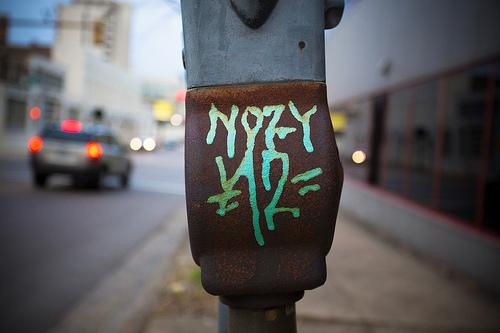Can you count how many cars are depicted in the image and their actions? There are two cars in the image; one is driving away from the scene, and the other is driving towards it with bright headlights on. Based on the image, identify two potential safety issues present. A possible safety issue is the old, rusty parking meter with a small hole, and another issue is the blurred vision of cars and buildings, making the scene unclear. Describe the sentiment or mood conveyed by the image. The mood of the image can be perceived as urban, chaotic, and somewhat neglected due to the rusty parking meter, graffiti and blurry quality. Examine the quality of the image and provide a brief description. The image has an outdoor setting and appears to be blurry, making some elements difficult to comprehend clearly. How many objects in the image are in motion? Explain what they are doing. There are three objects in motion: a silver vehicle driving down the street, a car with bright headlights in traffic, and an SUV driving down the road. List the features of the buildings seen in the background. The buildings have large windows, rust-red window frames, and are slightly out of focus. Are there any traffic lights in the image? If yes, please describe them. Yes, there is a yellow traffic light on a post, which might be a stoplight. What is the primary object mentioned in the image and its condition? The primary object in the image is a rusty parking meter with graffiti on it. Discuss the state of the parking meter in more detail. The parking meter is old and rusty with a small hole, a gray pole, and a metal latch. There is green graffiti that reads "nozy 12" on it. Identify the color and content of the graffiti on the parking meter. The graffiti is green and it reads "nozy 12." What color are the headlights of the car in traffic? Bright white Identify the objects situated on the sidewalk. Rusty parking meter, weeds growing Does the image show a bike riding on the sidewalk beside the rusty parking meter? There is no mention of a bike in any of the existing captions. Instead, they focus on the rusty parking meter and the sidewalk it is placed on. What is the color of the window frames on the corner building? Rust red Are the buildings in the image sharply focused and have a vivid blue color? The captions mention that "the buildings are out of focus" and "the window frames are a rust red." There is no mention of a vivid blue color for the buildings. What does the graffiti on the rusty parking meter say? Nozy 12 Describe the condition of the parking meter in the image. Old and rusty Describe the color and content of the graffiti found on the rusty parking meter. Green graffiti with the text "Nozy 12" What is the color of the graffiti lettering on the rusty parking meter? Turquoise Can you see a clear and legible street sign next to the yellow traffic light? The existing captions mention "this sign is not legible," indicating that there might be a sign present, but its content cannot be clearly read. State the color of the headlights on the car traveling towards the scene. White Are the buildings in the background in focus or out of focus? Out of focus Identify what the parking meter is placed on. Sidewalk Pick the odd one out: a rusty parking meter, a silver vehicle, a tall white building, and a green balloon. Green balloon Which direction is the SUV traveling away from the scene? Towards the left What is the metal latch attached to in the image? The parking meter Is there a dog standing near the rusty parking meter, wagging its tail? None of the existing captions mention a dog or any animal in the image. The focus is on inanimate objects like the rusty parking meter, vehicles, and buildings. Are the headlights of the car traveling down the road turned off and barely visible? The existing captions mention "bright headlights on a car" and "headlights of the car up the road," which suggest that the headlights are turned on and visible in the image. What is the state of the outdoor picture? Blurry Describe the state of the rusted base of the parking meter. Rusty Are there any holes in the parking meter? Yes, a small hole Is the graffiti on the parking meter bright pink and covering the entire meter? The graffiti is actually green and turquoise, and it does not cover the entire parking meter. The existing captions describe "green graffiti on brown background" and "turquoise letters on rusty part of parking meter." Which vehicle has round red brake lights? SUV What type of object is likely a stoplight? Round red light List the types of vehicles seen in the image. SUV, car Determine what is illegible in the image. Sign 